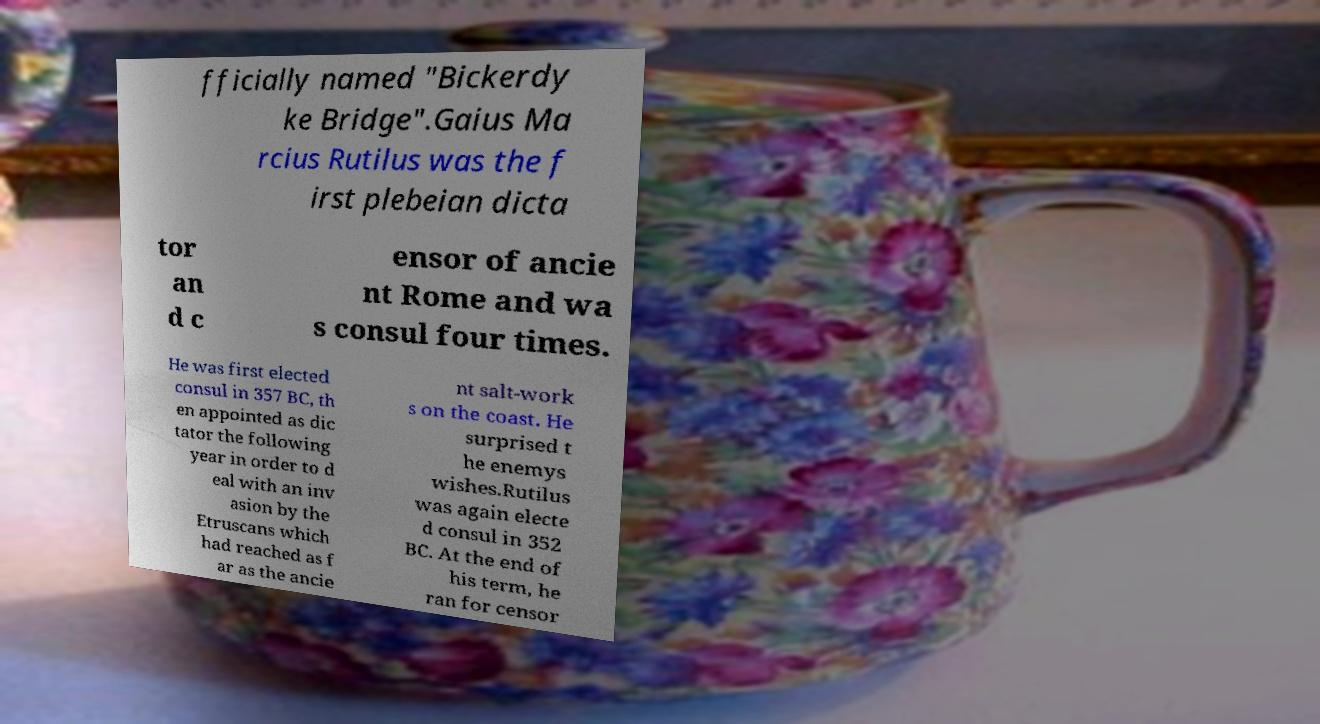I need the written content from this picture converted into text. Can you do that? fficially named "Bickerdy ke Bridge".Gaius Ma rcius Rutilus was the f irst plebeian dicta tor an d c ensor of ancie nt Rome and wa s consul four times. He was first elected consul in 357 BC, th en appointed as dic tator the following year in order to d eal with an inv asion by the Etruscans which had reached as f ar as the ancie nt salt-work s on the coast. He surprised t he enemys wishes.Rutilus was again electe d consul in 352 BC. At the end of his term, he ran for censor 